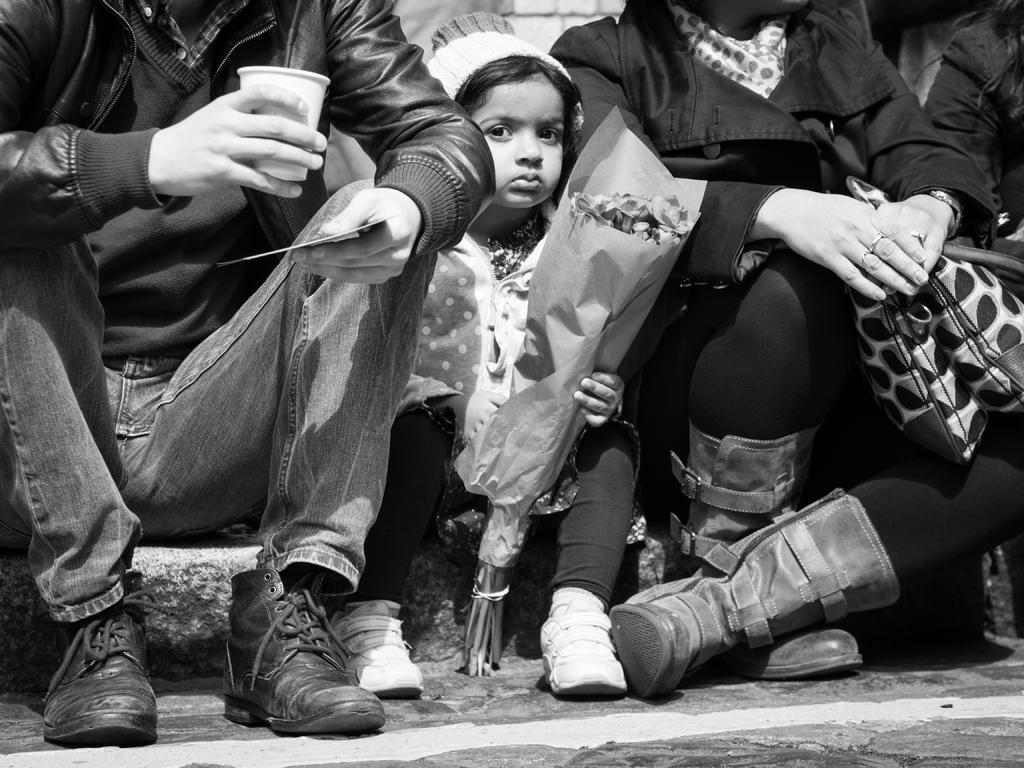Could you give a brief overview of what you see in this image? In this image there is a kid sitting and holding a flower bouquet , and there are two persons sitting , one person is holding a cup and another person is holding a bag. 